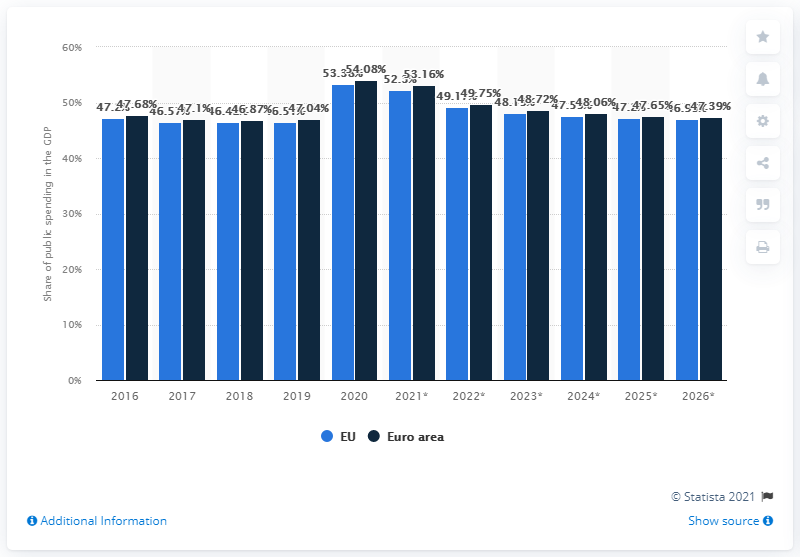Mention a couple of crucial points in this snapshot. As of 2020, the share of public spending of the European Union and the euro area in GDP has come to an end. In 2020, the public spending of the European Union accounted for 53.16% of the total budget. 